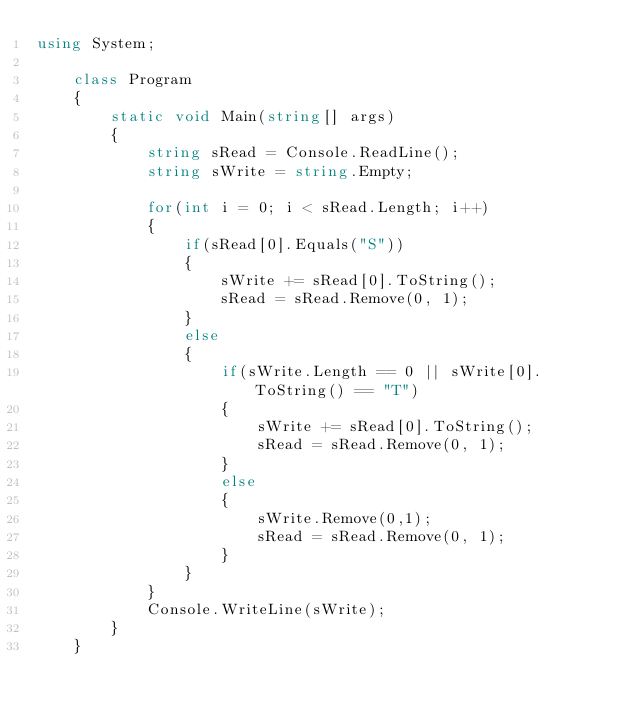Convert code to text. <code><loc_0><loc_0><loc_500><loc_500><_C#_>using System;

    class Program
    {
        static void Main(string[] args)
        {
            string sRead = Console.ReadLine();
            string sWrite = string.Empty;

            for(int i = 0; i < sRead.Length; i++)
            {
                if(sRead[0].Equals("S"))
                {
                    sWrite += sRead[0].ToString();
                    sRead = sRead.Remove(0, 1);
                }
                else
                {
                    if(sWrite.Length == 0 || sWrite[0].ToString() == "T")
                    {
                        sWrite += sRead[0].ToString();
                        sRead = sRead.Remove(0, 1);
                    }
                    else
                    {
                        sWrite.Remove(0,1);
                        sRead = sRead.Remove(0, 1);
                    }
                }
            }
            Console.WriteLine(sWrite);
        }
    }
</code> 